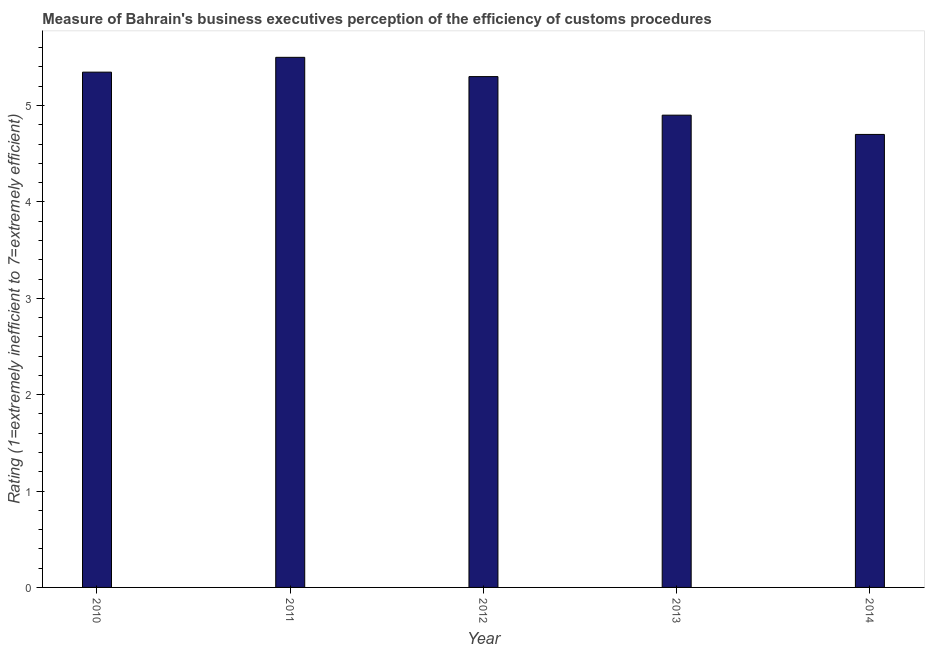Does the graph contain any zero values?
Keep it short and to the point. No. What is the title of the graph?
Keep it short and to the point. Measure of Bahrain's business executives perception of the efficiency of customs procedures. What is the label or title of the Y-axis?
Offer a terse response. Rating (1=extremely inefficient to 7=extremely efficient). Across all years, what is the maximum rating measuring burden of customs procedure?
Your answer should be very brief. 5.5. In which year was the rating measuring burden of customs procedure minimum?
Your answer should be very brief. 2014. What is the sum of the rating measuring burden of customs procedure?
Your answer should be compact. 25.75. What is the average rating measuring burden of customs procedure per year?
Provide a succinct answer. 5.15. What is the median rating measuring burden of customs procedure?
Your response must be concise. 5.3. Do a majority of the years between 2010 and 2013 (inclusive) have rating measuring burden of customs procedure greater than 5 ?
Your response must be concise. Yes. Is the difference between the rating measuring burden of customs procedure in 2011 and 2014 greater than the difference between any two years?
Your response must be concise. Yes. What is the difference between the highest and the second highest rating measuring burden of customs procedure?
Your answer should be compact. 0.15. Is the sum of the rating measuring burden of customs procedure in 2010 and 2012 greater than the maximum rating measuring burden of customs procedure across all years?
Offer a very short reply. Yes. What is the difference between the highest and the lowest rating measuring burden of customs procedure?
Your answer should be compact. 0.8. In how many years, is the rating measuring burden of customs procedure greater than the average rating measuring burden of customs procedure taken over all years?
Provide a short and direct response. 3. How many bars are there?
Keep it short and to the point. 5. What is the Rating (1=extremely inefficient to 7=extremely efficient) of 2010?
Provide a succinct answer. 5.35. What is the Rating (1=extremely inefficient to 7=extremely efficient) in 2012?
Offer a very short reply. 5.3. What is the Rating (1=extremely inefficient to 7=extremely efficient) of 2013?
Your response must be concise. 4.9. What is the Rating (1=extremely inefficient to 7=extremely efficient) of 2014?
Your answer should be compact. 4.7. What is the difference between the Rating (1=extremely inefficient to 7=extremely efficient) in 2010 and 2011?
Your answer should be very brief. -0.15. What is the difference between the Rating (1=extremely inefficient to 7=extremely efficient) in 2010 and 2012?
Keep it short and to the point. 0.05. What is the difference between the Rating (1=extremely inefficient to 7=extremely efficient) in 2010 and 2013?
Your answer should be compact. 0.45. What is the difference between the Rating (1=extremely inefficient to 7=extremely efficient) in 2010 and 2014?
Your answer should be compact. 0.65. What is the difference between the Rating (1=extremely inefficient to 7=extremely efficient) in 2011 and 2012?
Offer a very short reply. 0.2. What is the difference between the Rating (1=extremely inefficient to 7=extremely efficient) in 2011 and 2013?
Ensure brevity in your answer.  0.6. What is the difference between the Rating (1=extremely inefficient to 7=extremely efficient) in 2011 and 2014?
Your answer should be very brief. 0.8. What is the difference between the Rating (1=extremely inefficient to 7=extremely efficient) in 2012 and 2013?
Provide a succinct answer. 0.4. What is the ratio of the Rating (1=extremely inefficient to 7=extremely efficient) in 2010 to that in 2011?
Provide a short and direct response. 0.97. What is the ratio of the Rating (1=extremely inefficient to 7=extremely efficient) in 2010 to that in 2012?
Provide a short and direct response. 1.01. What is the ratio of the Rating (1=extremely inefficient to 7=extremely efficient) in 2010 to that in 2013?
Make the answer very short. 1.09. What is the ratio of the Rating (1=extremely inefficient to 7=extremely efficient) in 2010 to that in 2014?
Ensure brevity in your answer.  1.14. What is the ratio of the Rating (1=extremely inefficient to 7=extremely efficient) in 2011 to that in 2012?
Keep it short and to the point. 1.04. What is the ratio of the Rating (1=extremely inefficient to 7=extremely efficient) in 2011 to that in 2013?
Keep it short and to the point. 1.12. What is the ratio of the Rating (1=extremely inefficient to 7=extremely efficient) in 2011 to that in 2014?
Your answer should be very brief. 1.17. What is the ratio of the Rating (1=extremely inefficient to 7=extremely efficient) in 2012 to that in 2013?
Your answer should be compact. 1.08. What is the ratio of the Rating (1=extremely inefficient to 7=extremely efficient) in 2012 to that in 2014?
Offer a terse response. 1.13. What is the ratio of the Rating (1=extremely inefficient to 7=extremely efficient) in 2013 to that in 2014?
Your answer should be very brief. 1.04. 